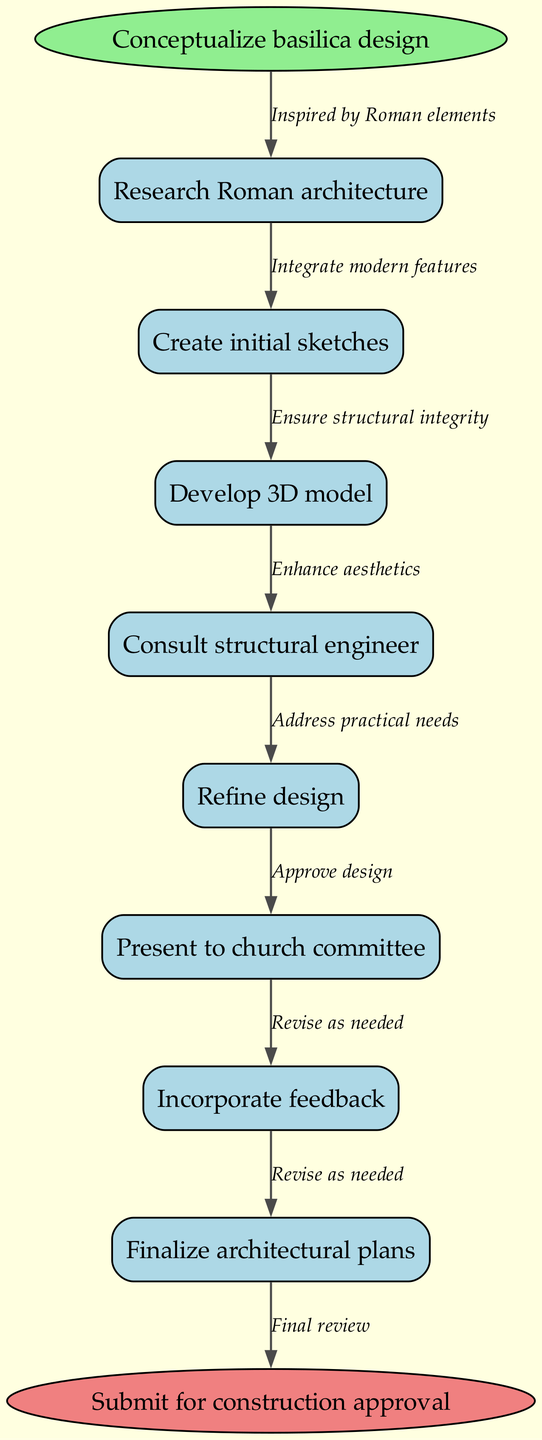What is the first step in the workflow? The diagram starts with the node labeled "Conceptualize basilica design," indicating that this is the first step in the workflow.
Answer: Conceptualize basilica design How many nodes are in the diagram? There are a total of eight nodes including the start and end nodes, which are connected in a flow.
Answer: Eight What node comes after "Create initial sketches"? Following "Create initial sketches," the next node is "Develop 3D model," according to the flow of the diagram.
Answer: Develop 3D model What is the last step before submitting for construction approval? The penultimate step before submission is labeled "Finalize architectural plans," which leads directly to the end node.
Answer: Finalize architectural plans Name a consulting action included in the workflow. The workflow includes "Consult structural engineer" as one of the consulting actions during the design process.
Answer: Consult structural engineer How many edges are there connecting the nodes in the diagram? Considering that there are eight nodes, there are seven edges connecting them sequentially through the workflow.
Answer: Seven What is the overall goal indicated at the end of the workflow? The end node of the diagram states the goal as "Submit for construction approval," summarizing the ultimate aim of the workflow process.
Answer: Submit for construction approval Which nodes reflect the feedback incorporation process? The nodes "Present to church committee" and "Incorporate feedback" specifically represent the feedback incorporation process in the workflow.
Answer: Present to church committee, Incorporate feedback What characteristic is ensured in the design through consulting? While consulting a structural engineer, the design focuses on "Ensure structural integrity," which highlights the importance of safety and stability in architecture.
Answer: Ensure structural integrity 